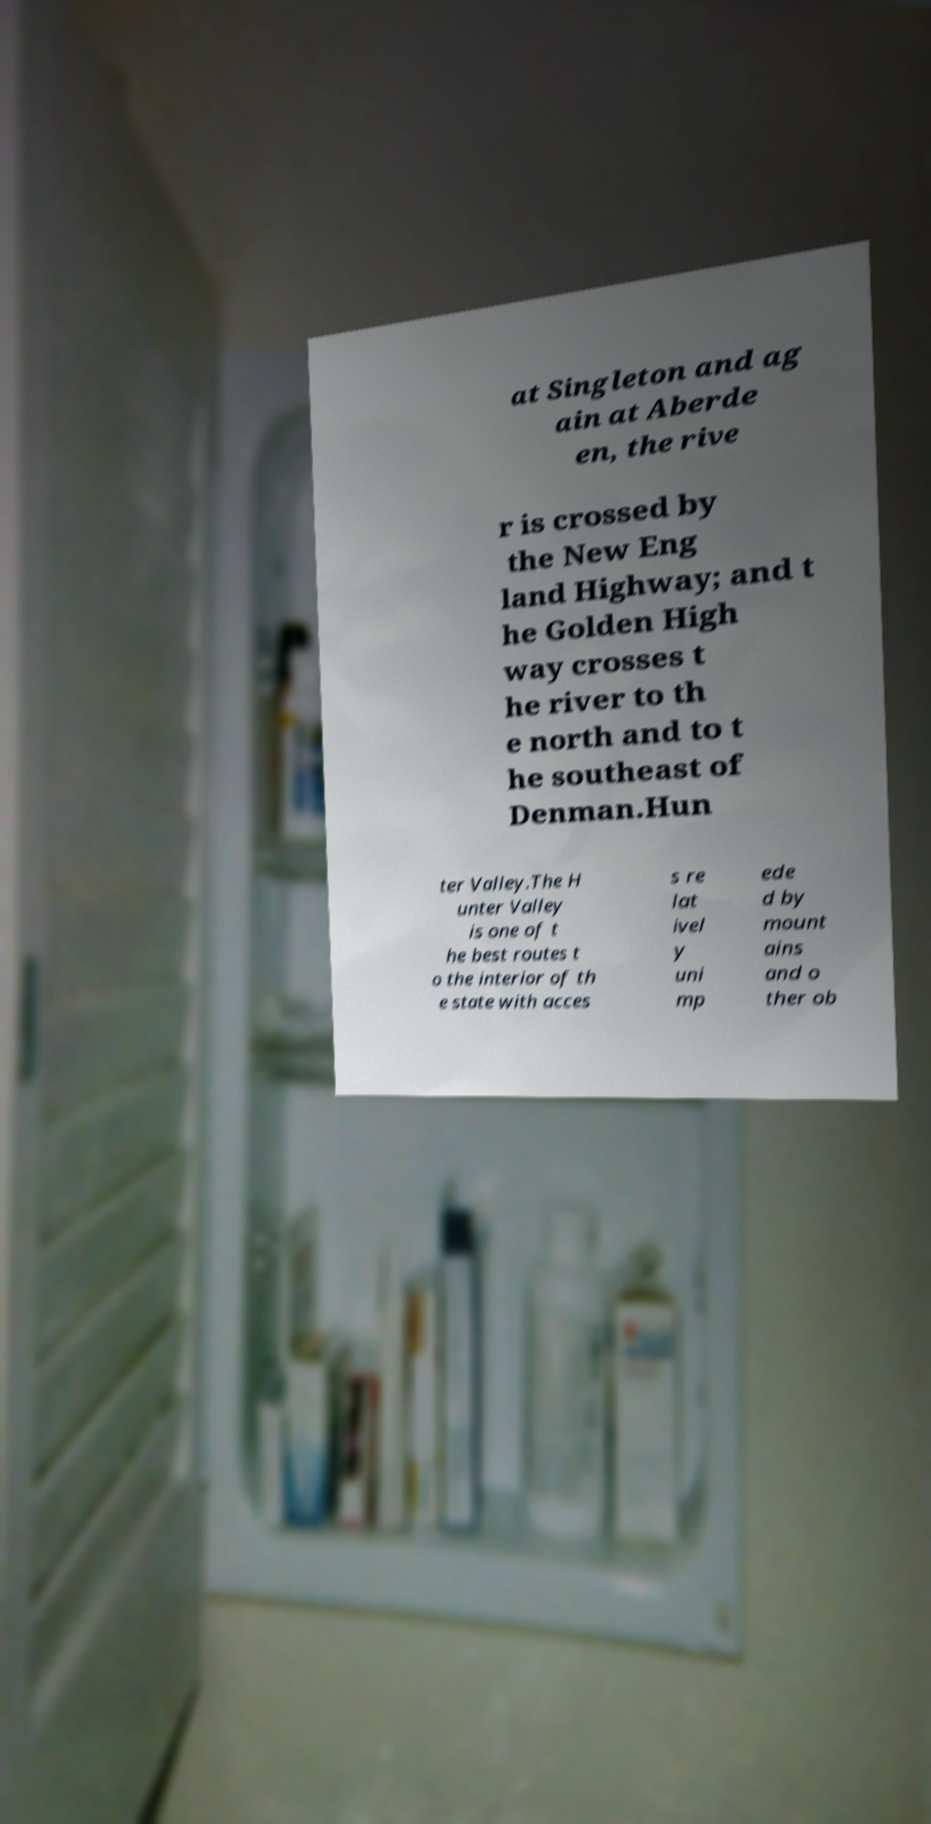Could you extract and type out the text from this image? at Singleton and ag ain at Aberde en, the rive r is crossed by the New Eng land Highway; and t he Golden High way crosses t he river to th e north and to t he southeast of Denman.Hun ter Valley.The H unter Valley is one of t he best routes t o the interior of th e state with acces s re lat ivel y uni mp ede d by mount ains and o ther ob 